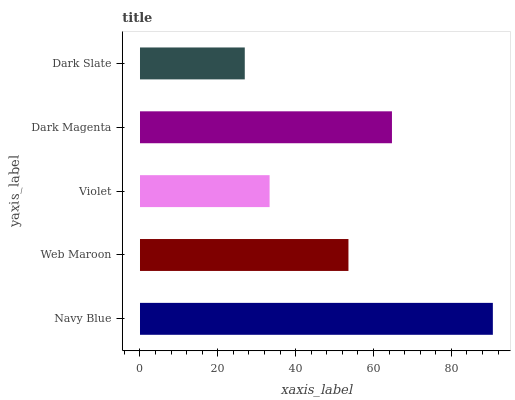Is Dark Slate the minimum?
Answer yes or no. Yes. Is Navy Blue the maximum?
Answer yes or no. Yes. Is Web Maroon the minimum?
Answer yes or no. No. Is Web Maroon the maximum?
Answer yes or no. No. Is Navy Blue greater than Web Maroon?
Answer yes or no. Yes. Is Web Maroon less than Navy Blue?
Answer yes or no. Yes. Is Web Maroon greater than Navy Blue?
Answer yes or no. No. Is Navy Blue less than Web Maroon?
Answer yes or no. No. Is Web Maroon the high median?
Answer yes or no. Yes. Is Web Maroon the low median?
Answer yes or no. Yes. Is Violet the high median?
Answer yes or no. No. Is Violet the low median?
Answer yes or no. No. 